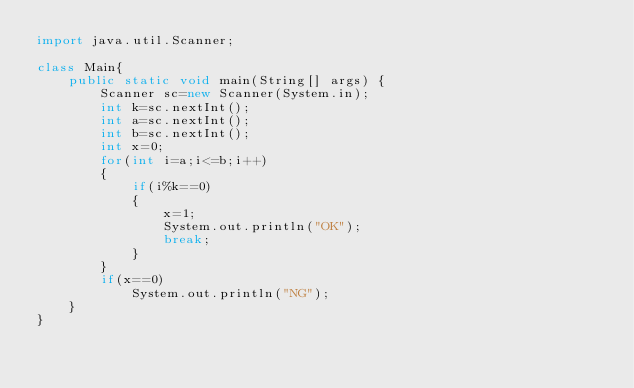<code> <loc_0><loc_0><loc_500><loc_500><_Java_>import java.util.Scanner;

class Main{
    public static void main(String[] args) {
        Scanner sc=new Scanner(System.in);
        int k=sc.nextInt();
        int a=sc.nextInt();
        int b=sc.nextInt();
        int x=0;
        for(int i=a;i<=b;i++)
        {
            if(i%k==0)
            {
                x=1;
                System.out.println("OK");
                break;
            }
        }
        if(x==0)
            System.out.println("NG");
    }
}</code> 